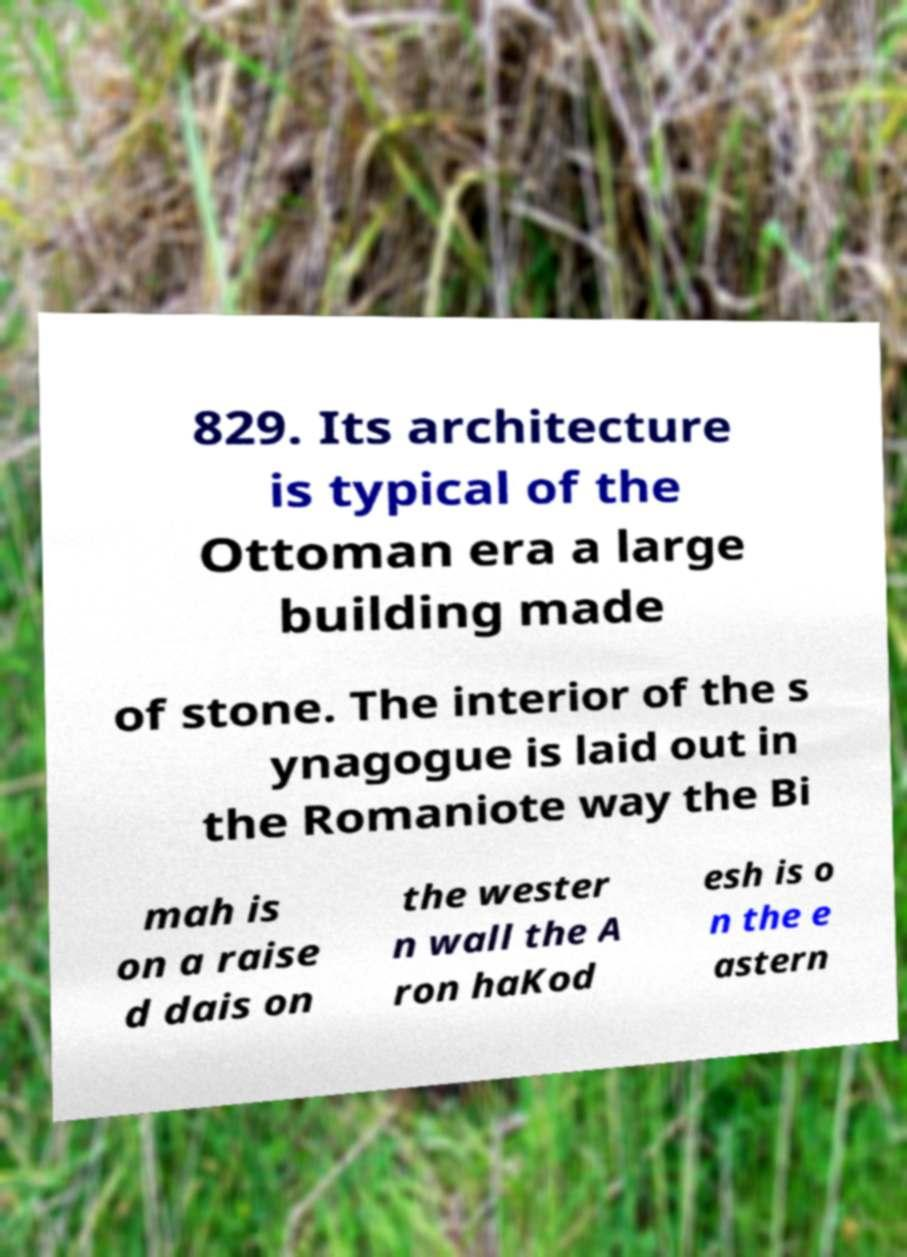For documentation purposes, I need the text within this image transcribed. Could you provide that? 829. Its architecture is typical of the Ottoman era a large building made of stone. The interior of the s ynagogue is laid out in the Romaniote way the Bi mah is on a raise d dais on the wester n wall the A ron haKod esh is o n the e astern 